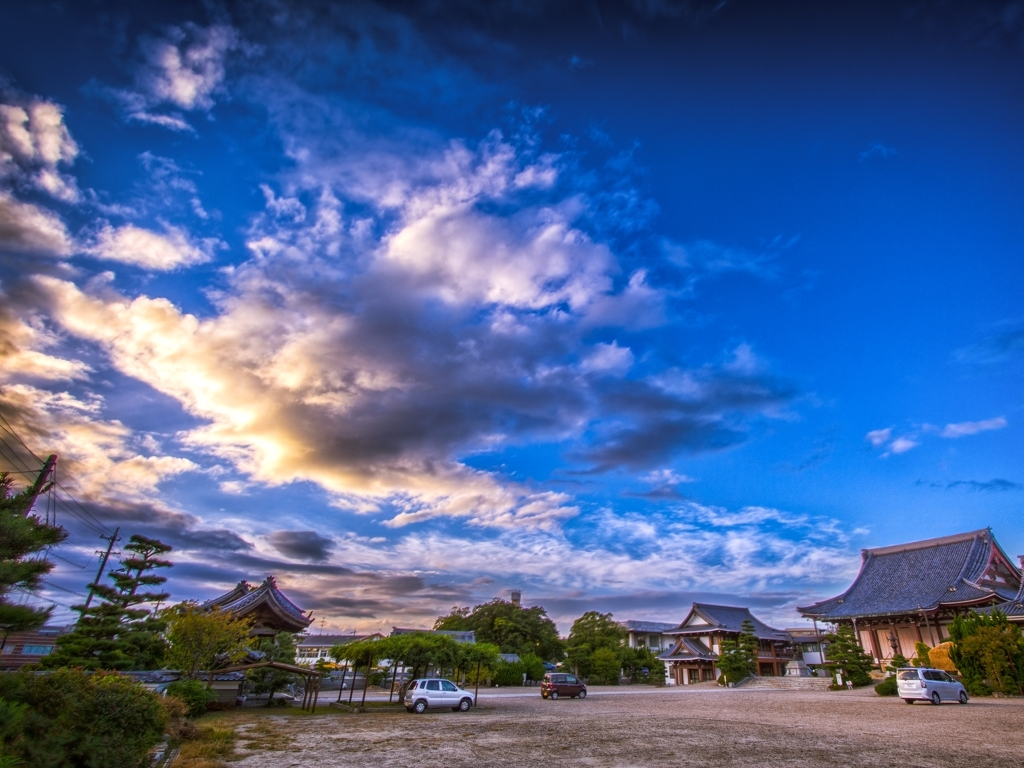What is the impression created by the color of the image?
A. dazzling
B. blurry
C. faded
Answer with the option's letter from the given choices directly.
 A. 